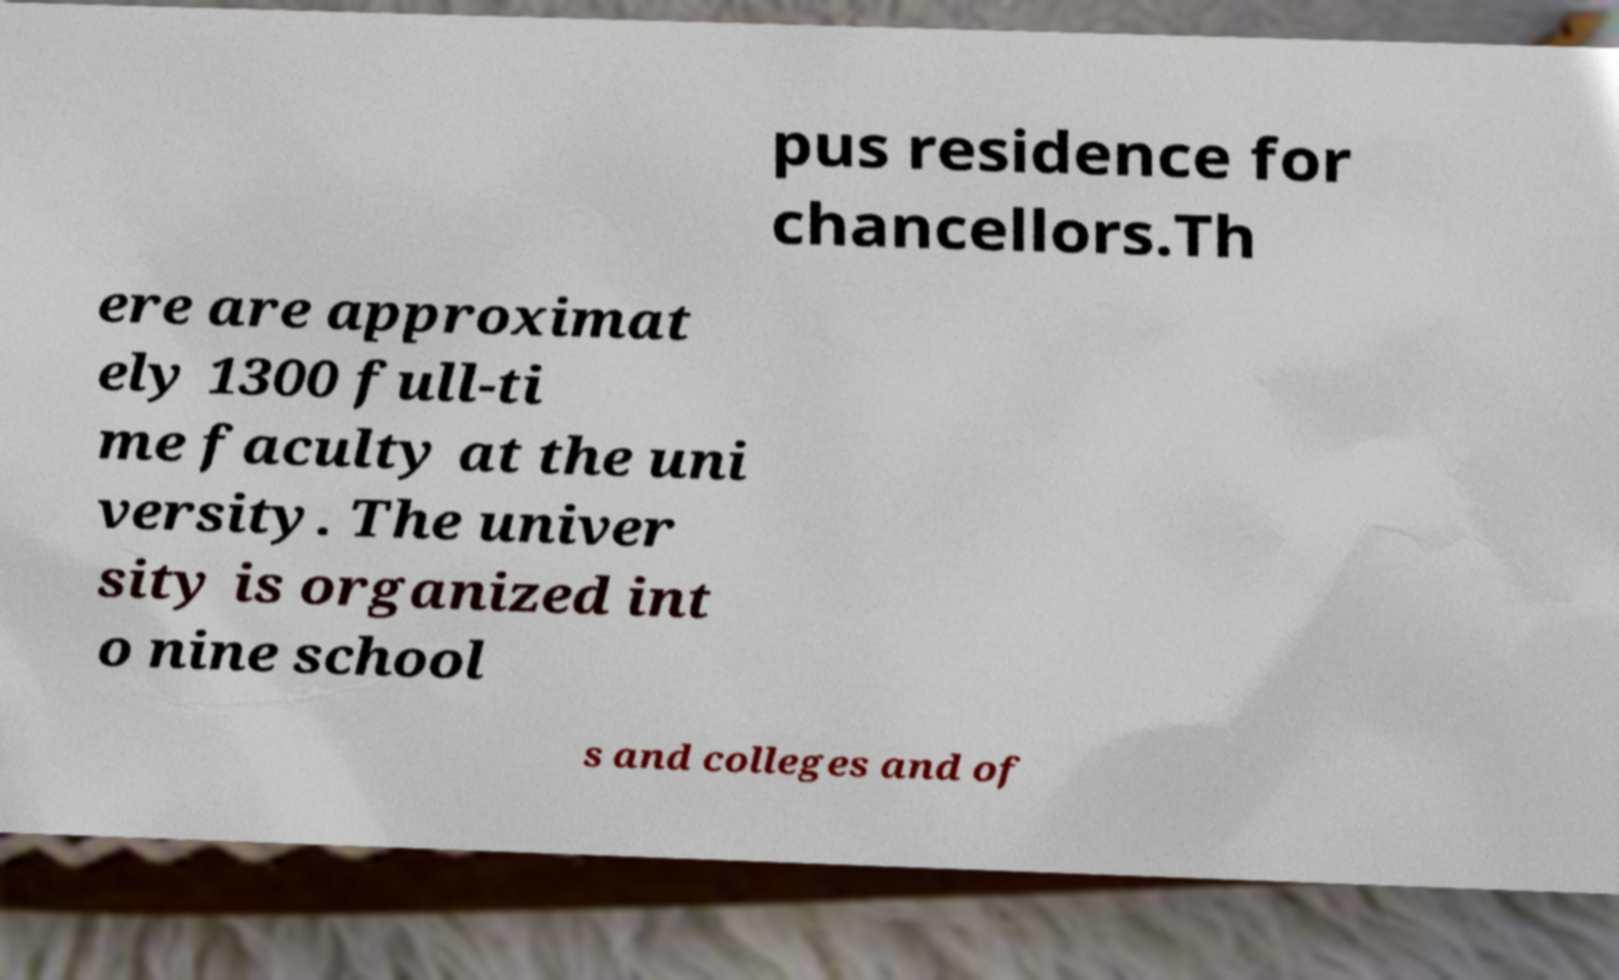I need the written content from this picture converted into text. Can you do that? pus residence for chancellors.Th ere are approximat ely 1300 full-ti me faculty at the uni versity. The univer sity is organized int o nine school s and colleges and of 